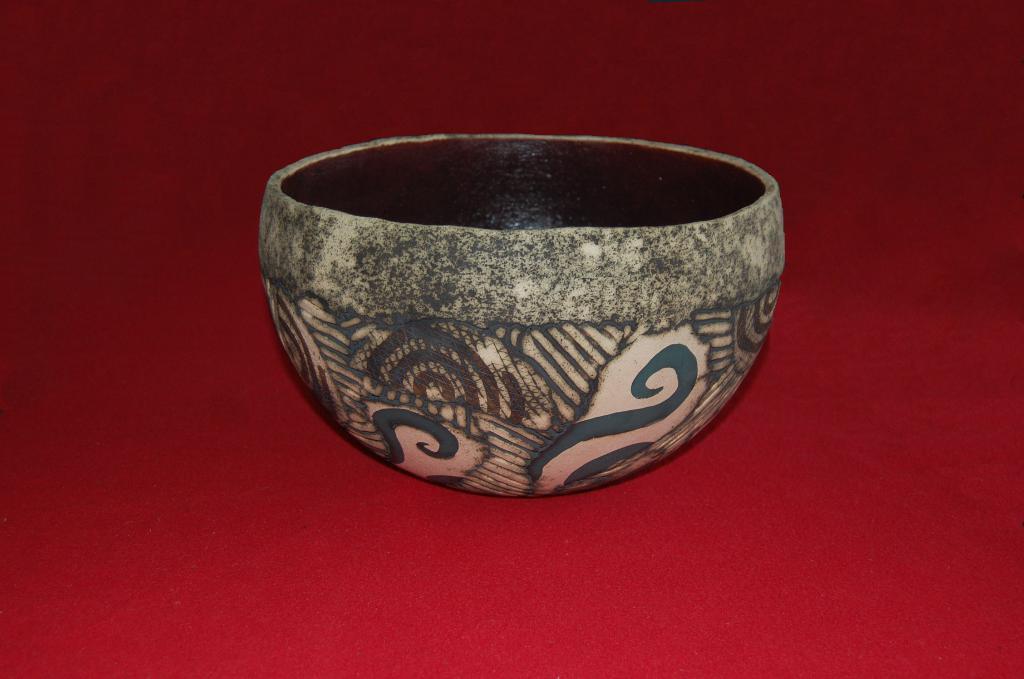Please provide a concise description of this image. In this image I can see a bowl on the red coloured surface. 